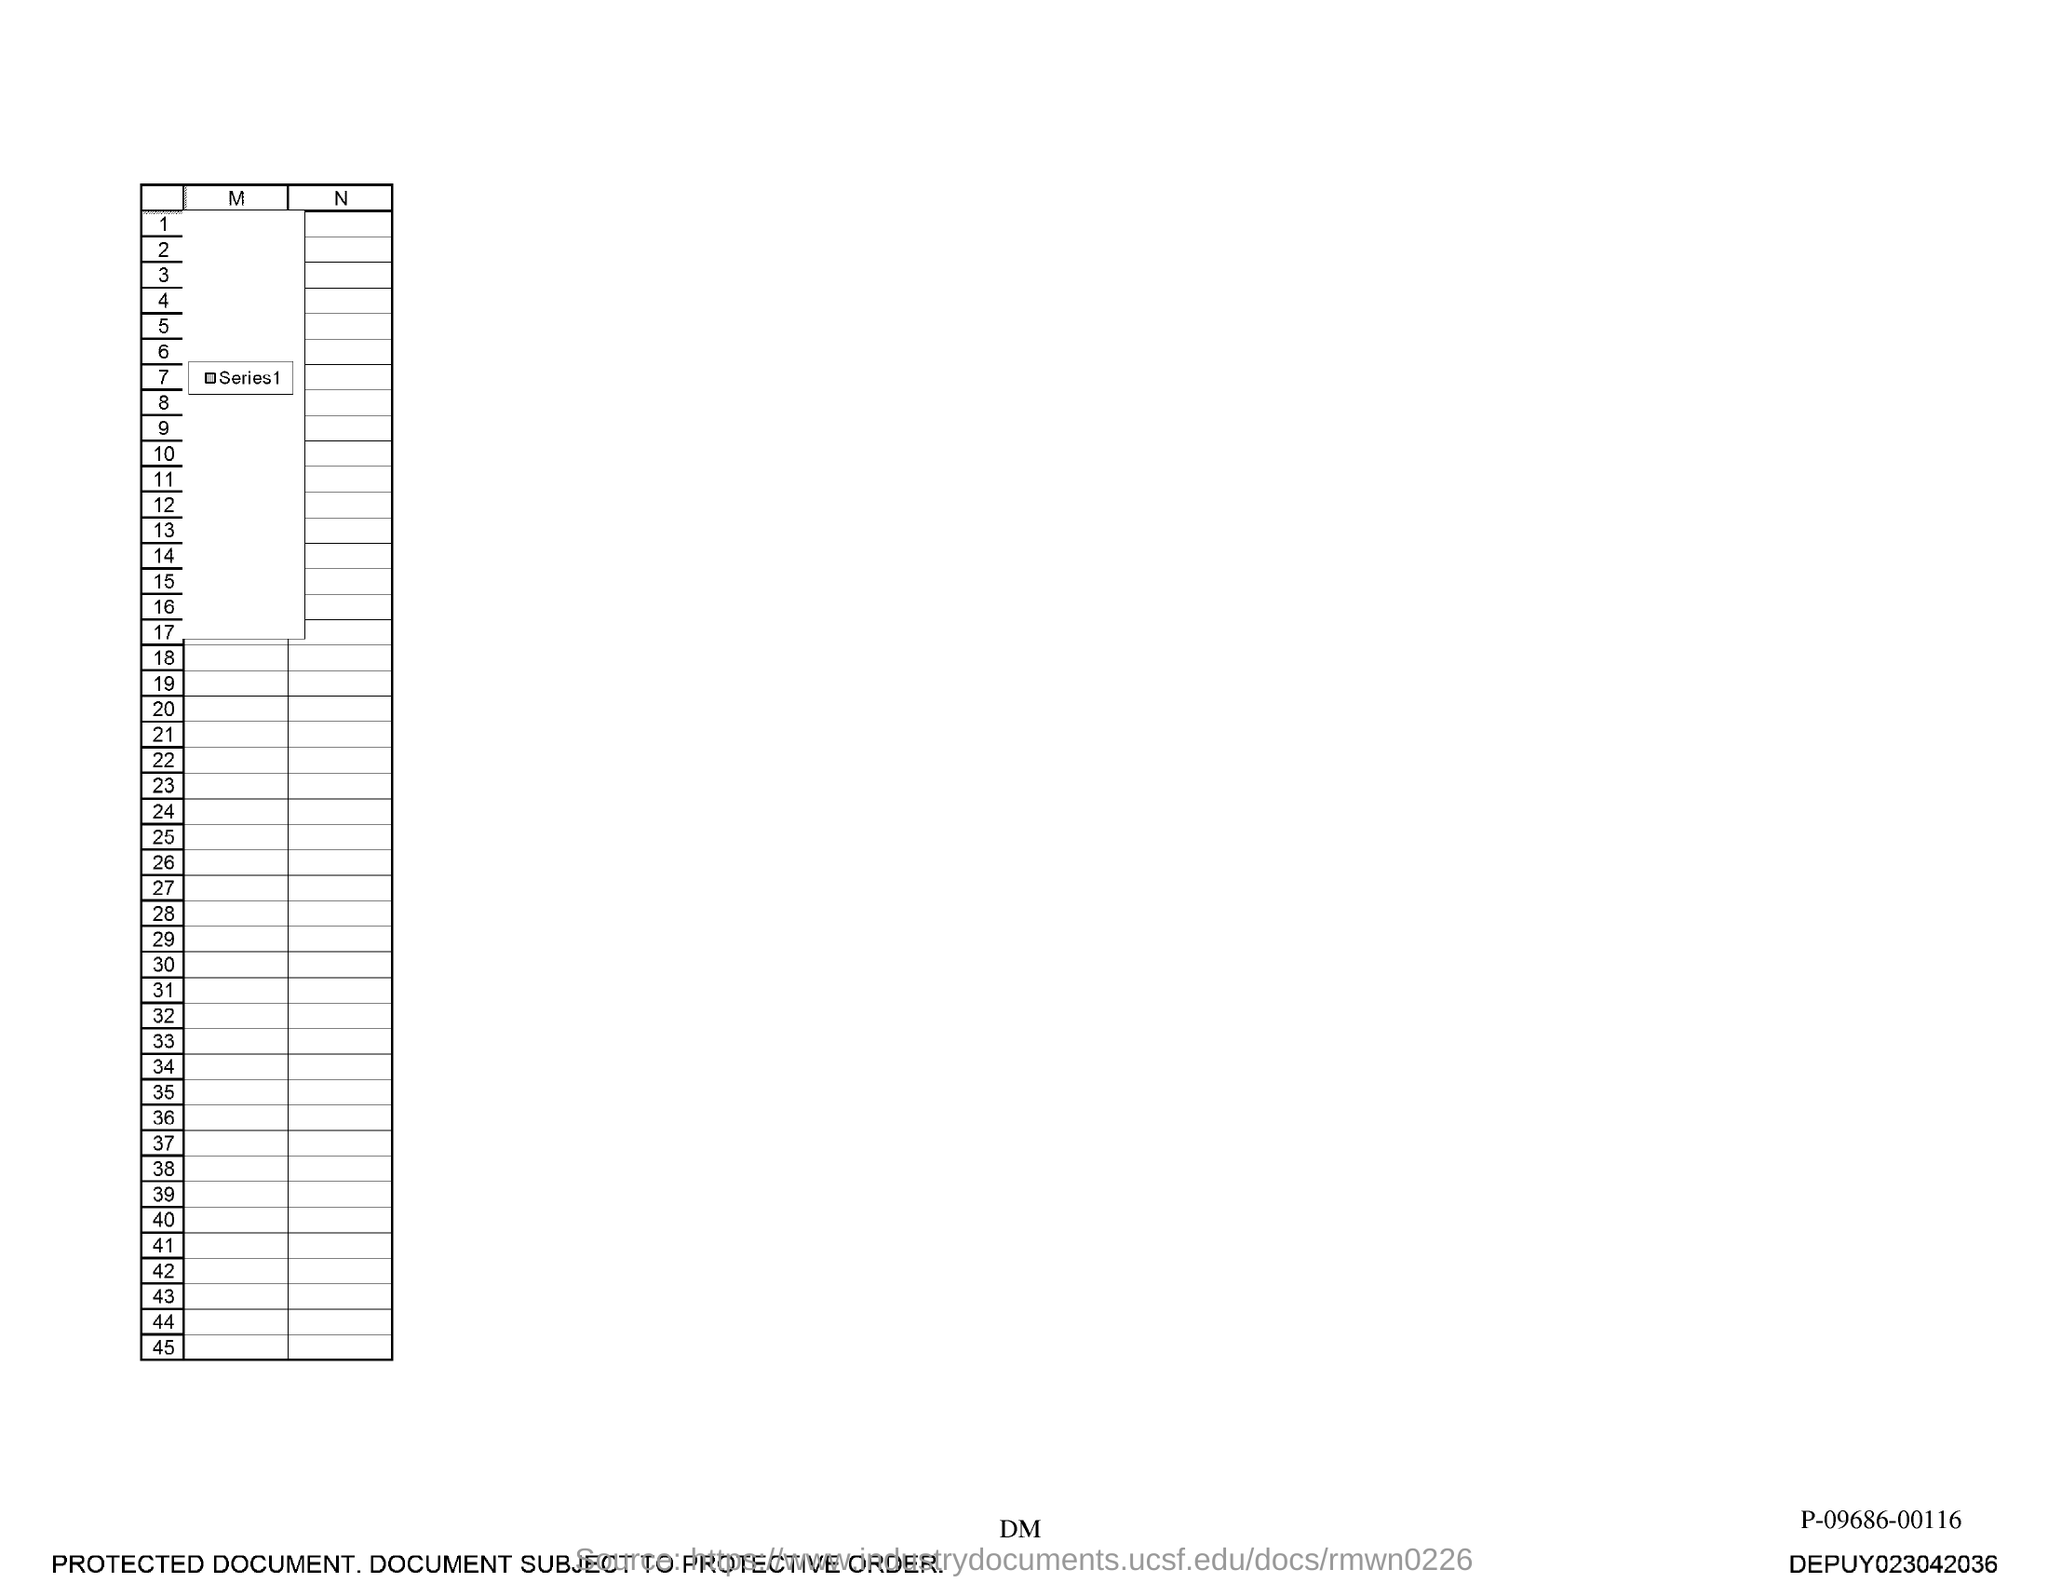Draw attention to some important aspects in this diagram. What is the last number in the first column? It is 45. 